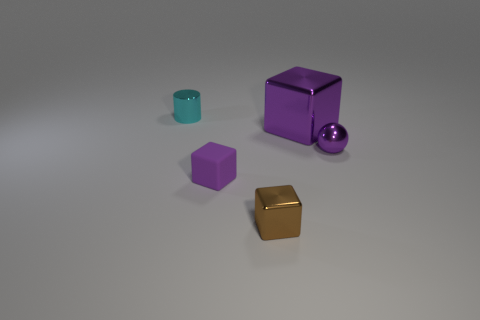Add 5 large cyan rubber cylinders. How many objects exist? 10 Subtract all balls. How many objects are left? 4 Add 5 big cyan rubber cylinders. How many big cyan rubber cylinders exist? 5 Subtract 2 purple blocks. How many objects are left? 3 Subtract all big metallic cubes. Subtract all blue rubber cylinders. How many objects are left? 4 Add 3 rubber blocks. How many rubber blocks are left? 4 